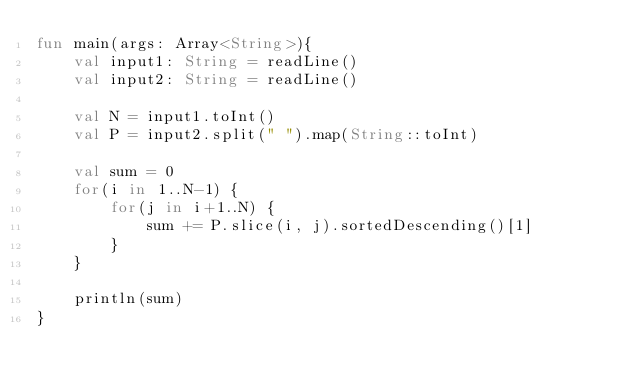Convert code to text. <code><loc_0><loc_0><loc_500><loc_500><_Kotlin_>fun main(args: Array<String>){
    val input1: String = readLine()
    val input2: String = readLine()

    val N = input1.toInt()
    val P = input2.split(" ").map(String::toInt)

    val sum = 0
    for(i in 1..N-1) {
        for(j in i+1..N) {
            sum += P.slice(i, j).sortedDescending()[1]
        }
    }

    println(sum)
}</code> 